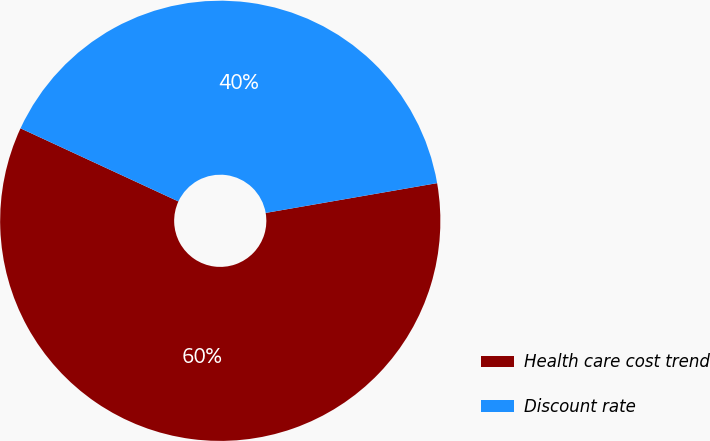<chart> <loc_0><loc_0><loc_500><loc_500><pie_chart><fcel>Health care cost trend<fcel>Discount rate<nl><fcel>59.64%<fcel>40.36%<nl></chart> 